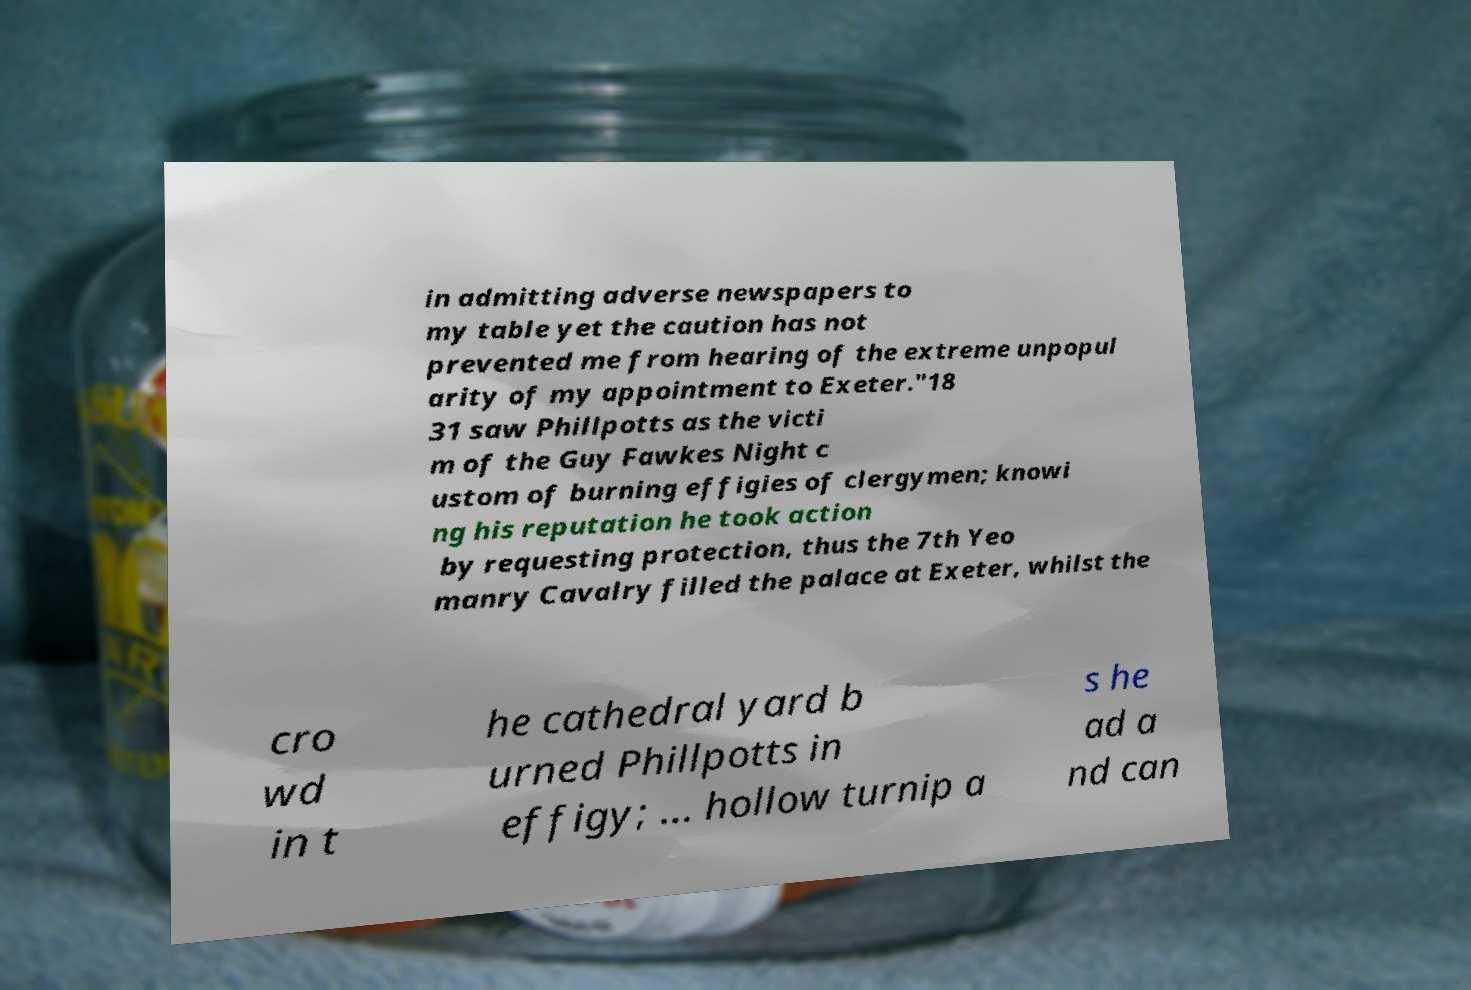Could you extract and type out the text from this image? in admitting adverse newspapers to my table yet the caution has not prevented me from hearing of the extreme unpopul arity of my appointment to Exeter."18 31 saw Phillpotts as the victi m of the Guy Fawkes Night c ustom of burning effigies of clergymen; knowi ng his reputation he took action by requesting protection, thus the 7th Yeo manry Cavalry filled the palace at Exeter, whilst the cro wd in t he cathedral yard b urned Phillpotts in effigy; ... hollow turnip a s he ad a nd can 